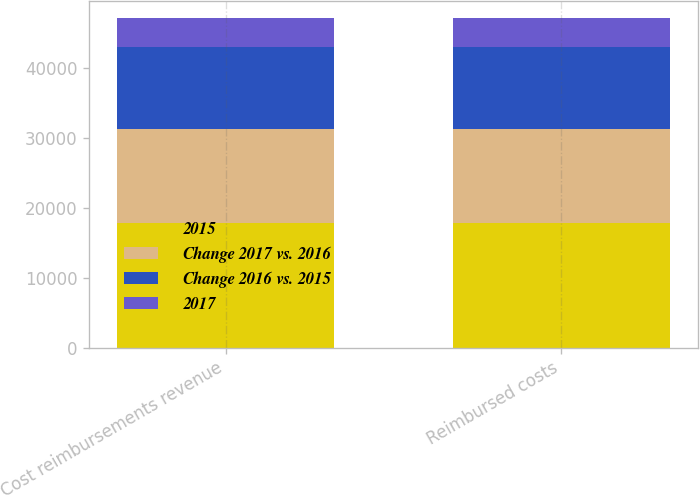<chart> <loc_0><loc_0><loc_500><loc_500><stacked_bar_chart><ecel><fcel>Cost reimbursements revenue<fcel>Reimbursed costs<nl><fcel>2015<fcel>17765<fcel>17765<nl><fcel>Change 2017 vs. 2016<fcel>13546<fcel>13546<nl><fcel>Change 2016 vs. 2015<fcel>11630<fcel>11630<nl><fcel>2017<fcel>4219<fcel>4219<nl></chart> 